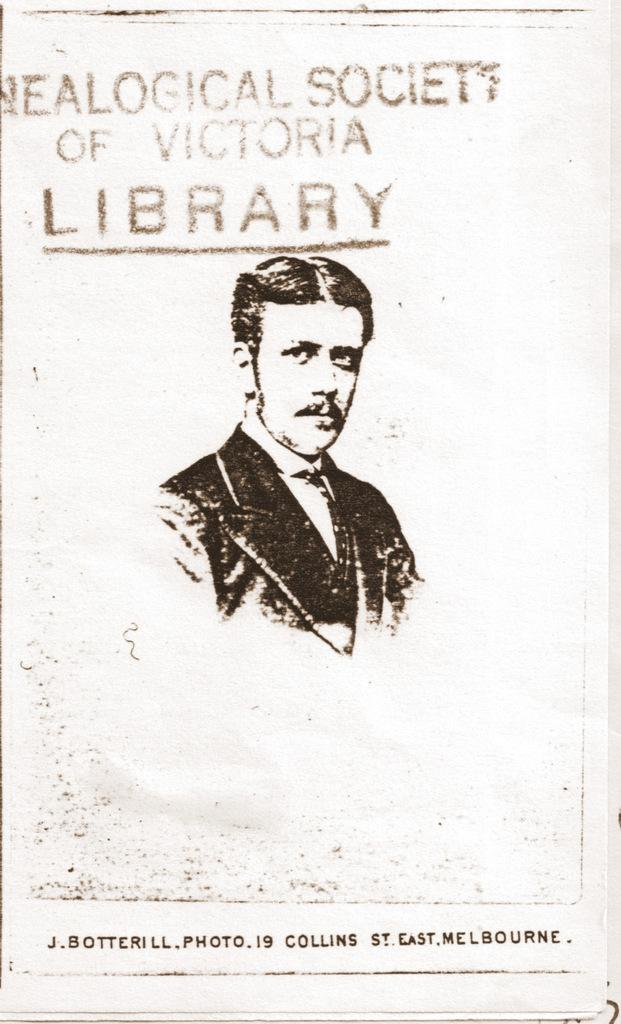What is present in the image that contains text? There is a paper in the image that contains text. What is the person in the image doing? The person in the image is drawing. How much dust is visible on the floor in the image? There is no mention of dust or a floor in the provided facts, so we cannot answer this question. 